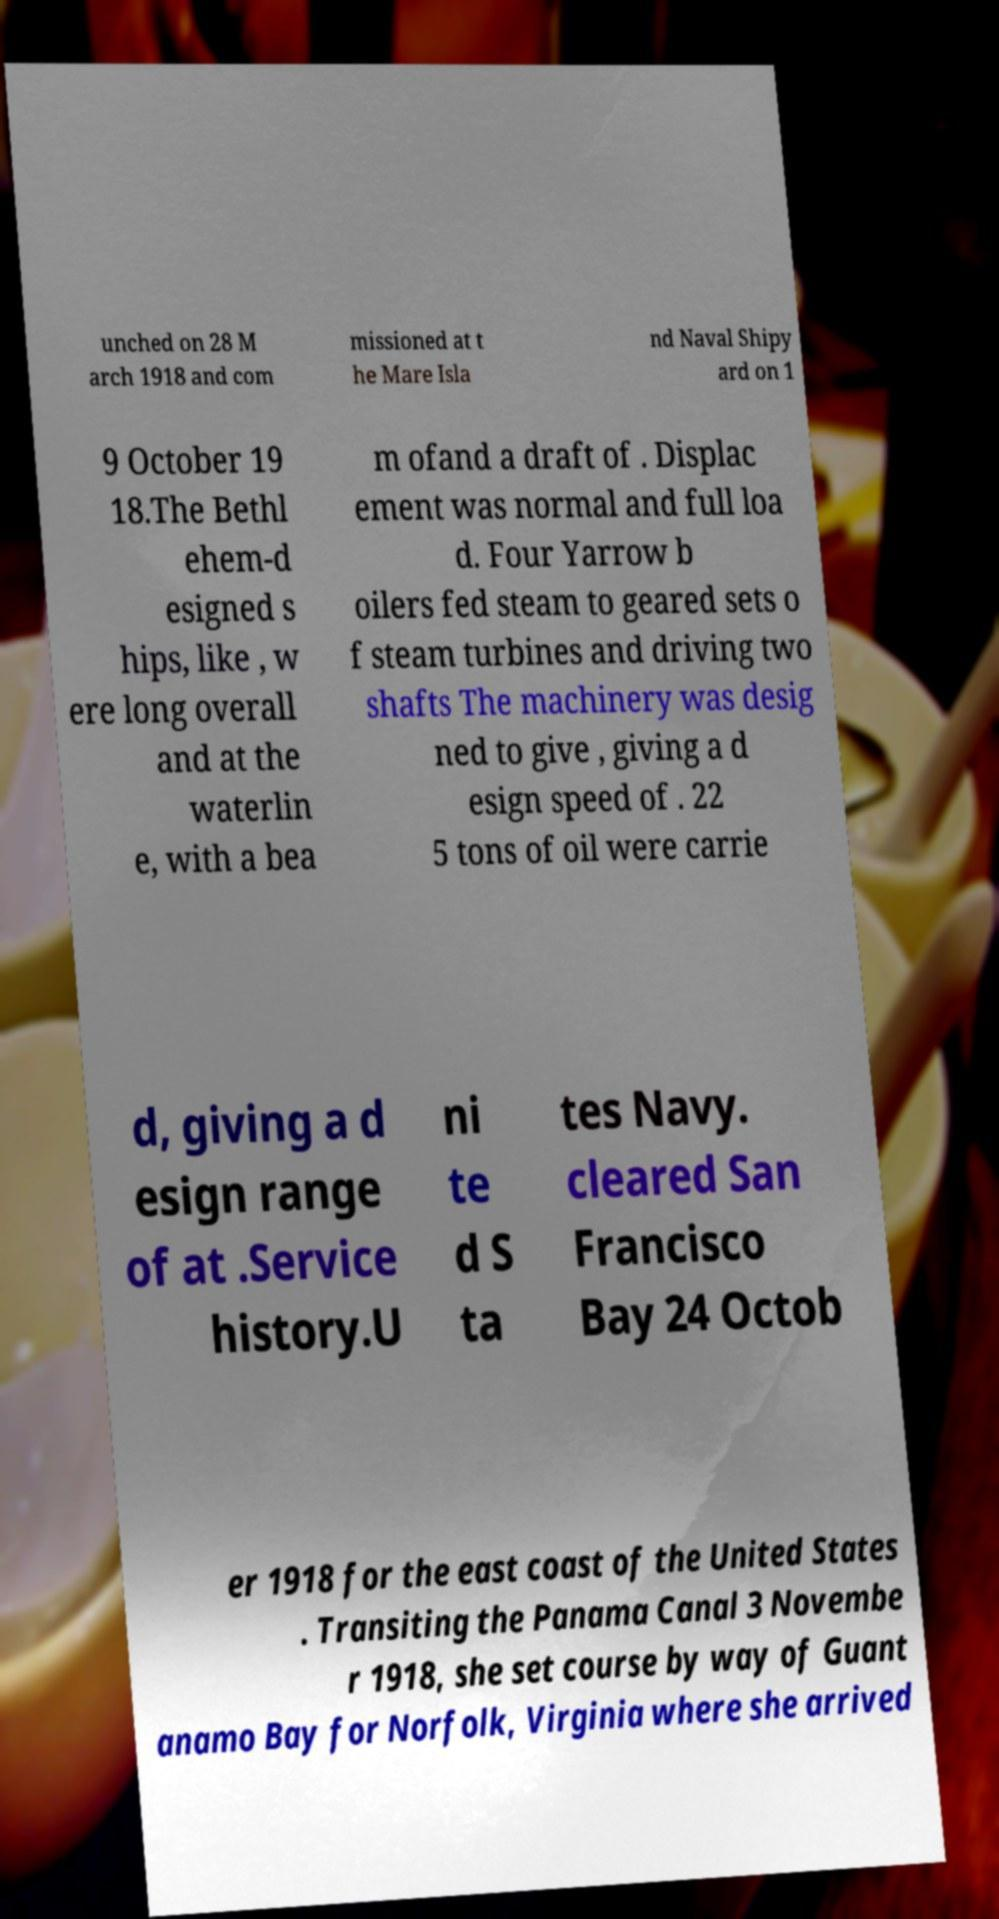What messages or text are displayed in this image? I need them in a readable, typed format. unched on 28 M arch 1918 and com missioned at t he Mare Isla nd Naval Shipy ard on 1 9 October 19 18.The Bethl ehem-d esigned s hips, like , w ere long overall and at the waterlin e, with a bea m ofand a draft of . Displac ement was normal and full loa d. Four Yarrow b oilers fed steam to geared sets o f steam turbines and driving two shafts The machinery was desig ned to give , giving a d esign speed of . 22 5 tons of oil were carrie d, giving a d esign range of at .Service history.U ni te d S ta tes Navy. cleared San Francisco Bay 24 Octob er 1918 for the east coast of the United States . Transiting the Panama Canal 3 Novembe r 1918, she set course by way of Guant anamo Bay for Norfolk, Virginia where she arrived 